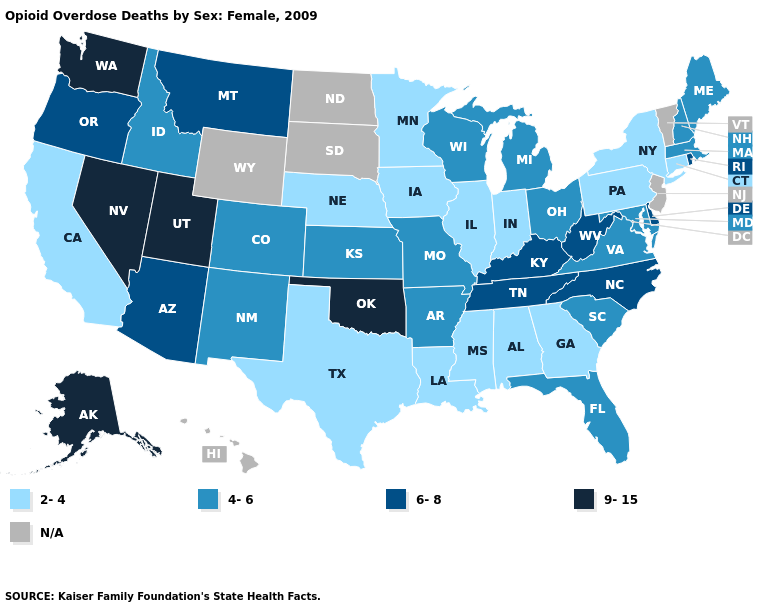What is the value of West Virginia?
Concise answer only. 6-8. What is the value of Oklahoma?
Answer briefly. 9-15. What is the lowest value in the USA?
Be succinct. 2-4. What is the value of Delaware?
Short answer required. 6-8. What is the highest value in the MidWest ?
Keep it brief. 4-6. Name the states that have a value in the range 6-8?
Keep it brief. Arizona, Delaware, Kentucky, Montana, North Carolina, Oregon, Rhode Island, Tennessee, West Virginia. Which states have the highest value in the USA?
Concise answer only. Alaska, Nevada, Oklahoma, Utah, Washington. Name the states that have a value in the range 4-6?
Give a very brief answer. Arkansas, Colorado, Florida, Idaho, Kansas, Maine, Maryland, Massachusetts, Michigan, Missouri, New Hampshire, New Mexico, Ohio, South Carolina, Virginia, Wisconsin. What is the value of New York?
Quick response, please. 2-4. What is the highest value in the Northeast ?
Be succinct. 6-8. What is the value of Wisconsin?
Keep it brief. 4-6. Name the states that have a value in the range N/A?
Answer briefly. Hawaii, New Jersey, North Dakota, South Dakota, Vermont, Wyoming. Name the states that have a value in the range 2-4?
Short answer required. Alabama, California, Connecticut, Georgia, Illinois, Indiana, Iowa, Louisiana, Minnesota, Mississippi, Nebraska, New York, Pennsylvania, Texas. Which states have the lowest value in the West?
Be succinct. California. Name the states that have a value in the range 9-15?
Short answer required. Alaska, Nevada, Oklahoma, Utah, Washington. 